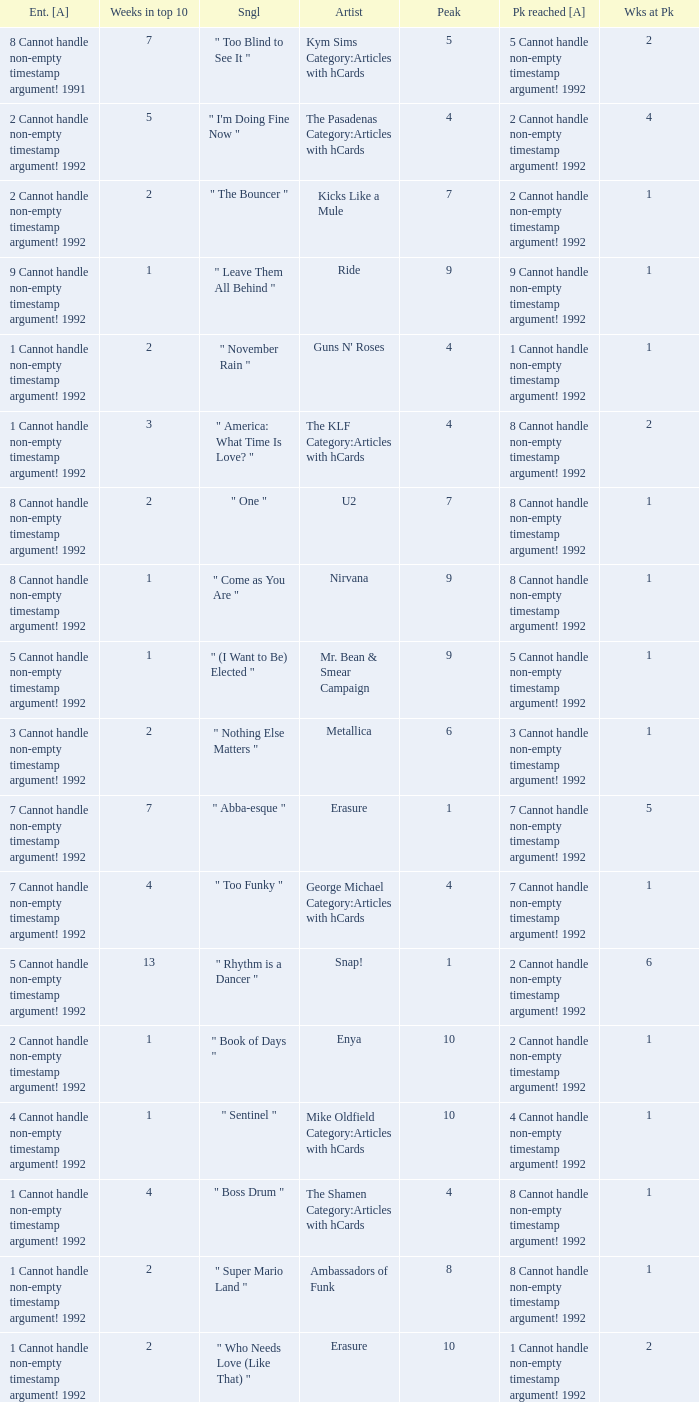If the peak is 9, how many weeks was it in the top 10? 1.0. 